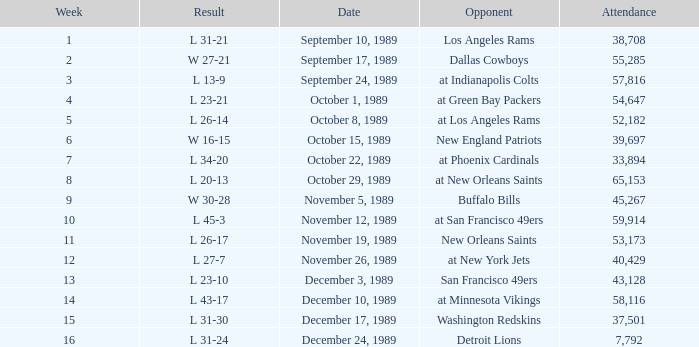On September 10, 1989 how many people attended the game? 38708.0. 